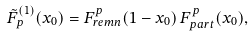<formula> <loc_0><loc_0><loc_500><loc_500>\tilde { F } _ { p } ^ { ( 1 ) } ( x _ { 0 } ) = F _ { r e m n } ^ { p } ( 1 - x _ { 0 } ) \, F _ { p a r t } ^ { p } ( x _ { 0 } ) ,</formula> 